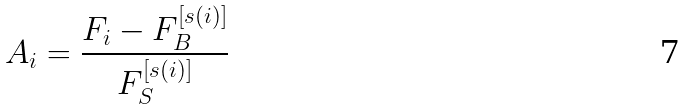<formula> <loc_0><loc_0><loc_500><loc_500>A _ { i } = \frac { F _ { i } - F _ { B } ^ { [ s ( i ) ] } } { F _ { S } ^ { [ s ( i ) ] } }</formula> 